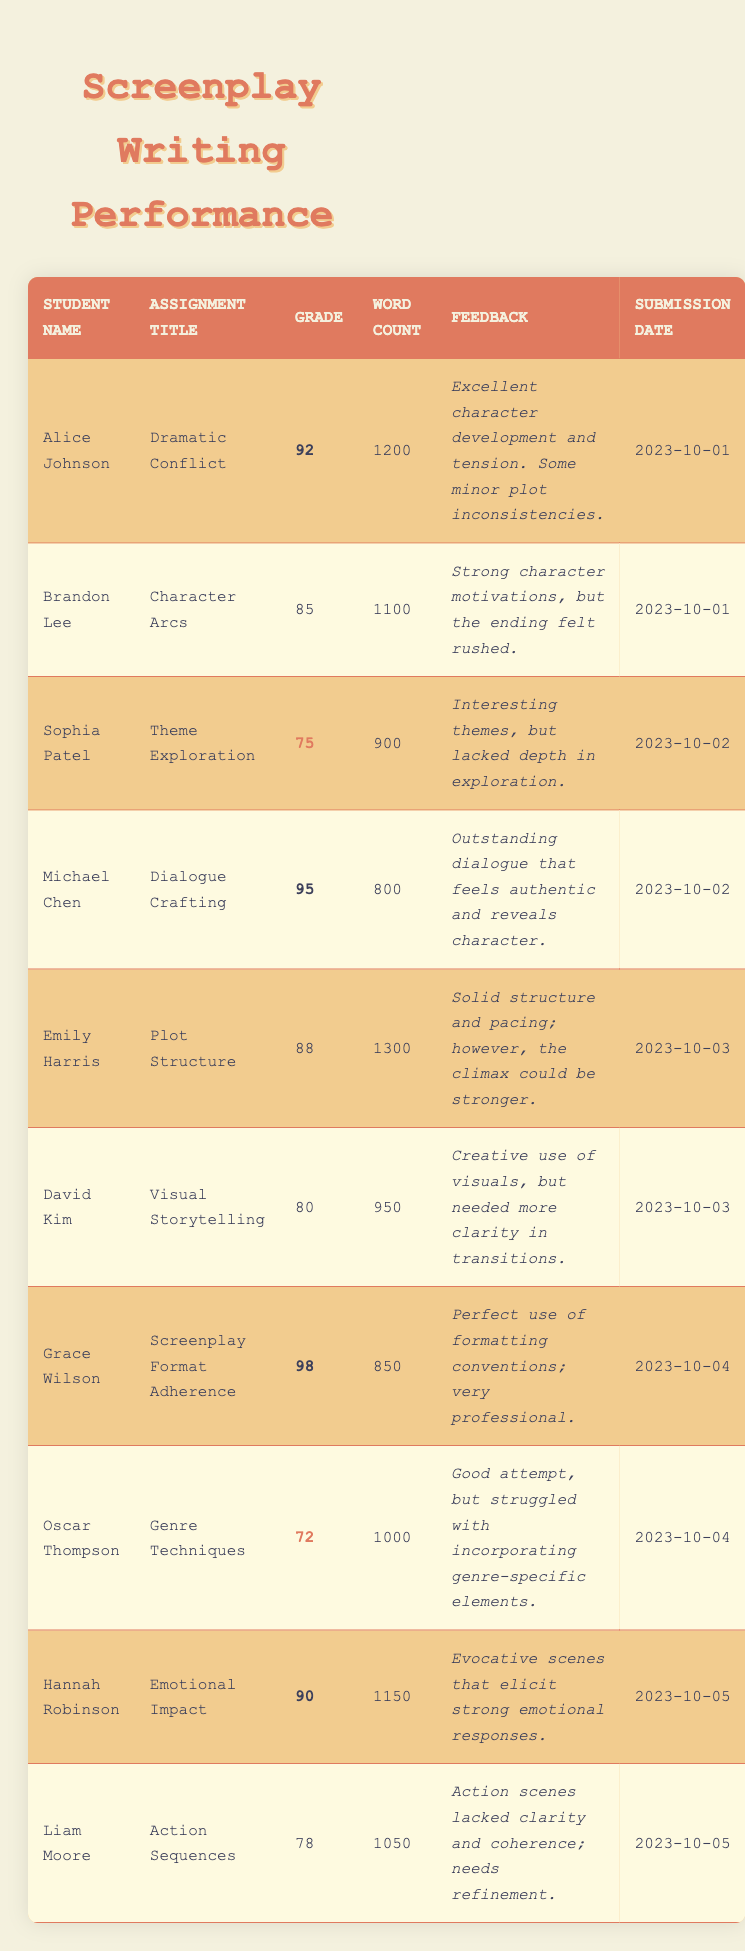What grade did Grace Wilson receive for her assignment? Grace Wilson's grade can be found in the table under her name, which shows a grade of 98 for her assignment titled "Screenplay Format Adherence."
Answer: 98 How many words did Michael Chen write for his "Dialogue Crafting" assignment? The table lists Michael Chen's word count as 800 words for his "Dialogue Crafting" assignment.
Answer: 800 Which student had the lowest grade and what was it? To find the lowest grade, I look at the grades in the table. Oscar Thompson received a grade of 72, which is the lowest among all students.
Answer: 72 What is the average grade of all students? To calculate the average grade, I sum up all grades: 92 + 85 + 75 + 95 + 88 + 80 + 98 + 72 + 90 + 78 =  930. There are 10 students, so the average grade is 930/10 = 93.
Answer: 93 Did any student receive a grade of 95 or higher? In the table, both Michael Chen and Grace Wilson received grades of 95 and 98, respectively, confirming that at least one student achieved this benchmark.
Answer: Yes How many students scored below 80, and who are they? First, we determine the grades below 80. The students Oscar Thompson (72) and Liam Moore (78) both scored below 80, totaling 2 students.
Answer: 2 students: Oscar Thompson and Liam Moore What was the feedback for Brandon Lee's assignment? The feedback is available in the table under Brandon Lee’s entry, which states, "Strong character motivations, but the ending felt rushed."
Answer: Strong character motivations, but the ending felt rushed Which assignment had the highest word count and how many words were written? To find the highest word count, I compare the word counts listed in the table. Emily Harris’s assignment "Plot Structure" had the highest word count of 1300 words.
Answer: 1300 How many students submitted their assignments on October 1st? The table shows that both Alice Johnson and Brandon Lee submitted their assignments on October 1st, making a total of 2 students.
Answer: 2 students Which assignment title had the best feedback? I examine the feedback for grades above 90. Michael Chen's "Dialogue Crafting" received the strongest feedback: "Outstanding dialogue that feels authentic and reveals character."
Answer: Dialogue Crafting What is the difference between the highest and the lowest grades? The highest grade is 98 (Grace Wilson) and the lowest is 72 (Oscar Thompson). The difference is calculated as 98 - 72 = 26.
Answer: 26 